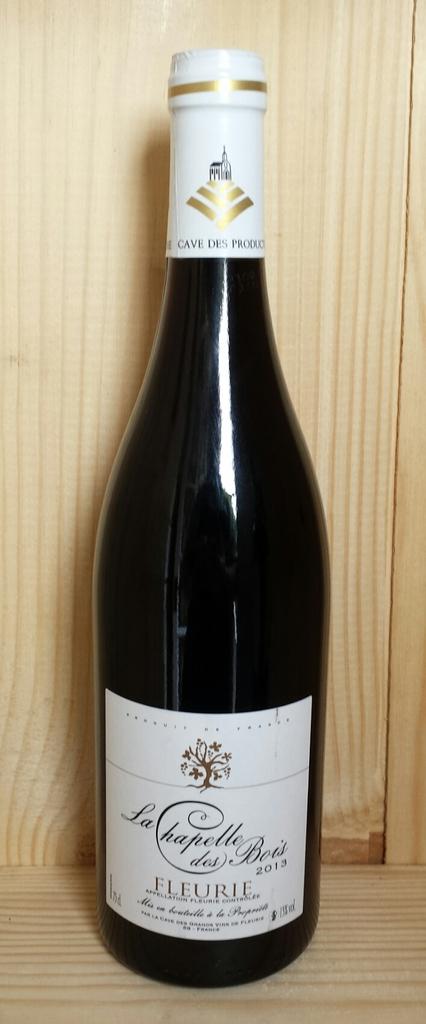What year is this wine?
Ensure brevity in your answer.  2013. What brand is the wine?
Offer a very short reply. Fleurie. 